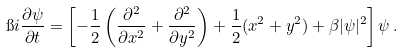Convert formula to latex. <formula><loc_0><loc_0><loc_500><loc_500>\i i \frac { \partial \psi } { \partial t } = \left [ - \frac { 1 } { 2 } \left ( \frac { \partial ^ { 2 } } { \partial x ^ { 2 } } + \frac { \partial ^ { 2 } } { \partial y ^ { 2 } } \right ) + \frac { 1 } { 2 } ( x ^ { 2 } + y ^ { 2 } ) + \beta | \psi | ^ { 2 } \right ] \psi \, .</formula> 